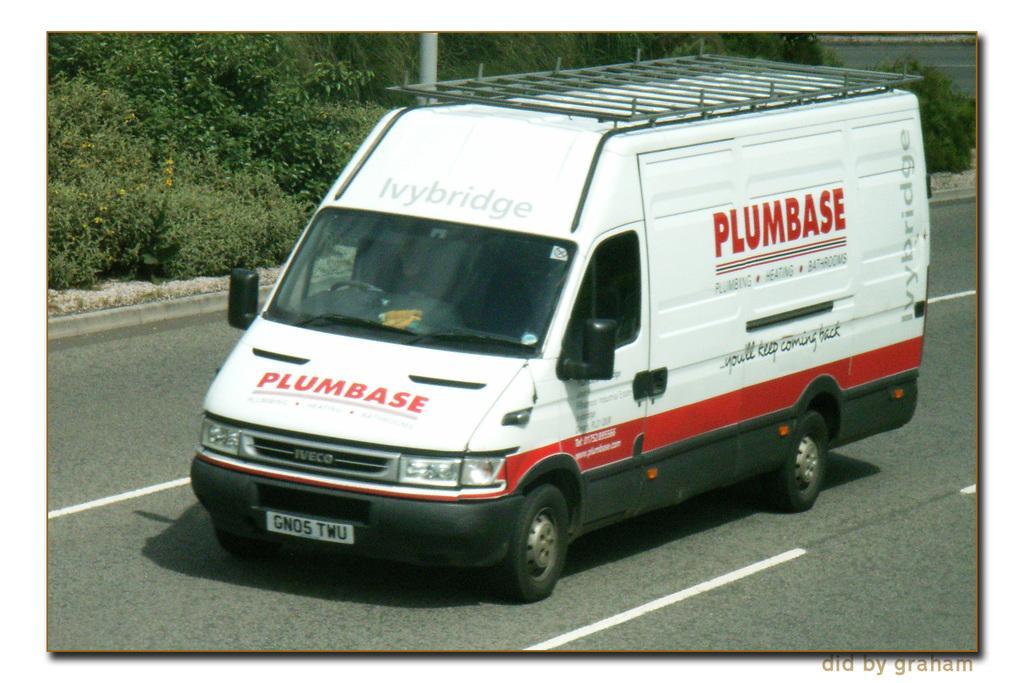Describe this image in one or two sentences. This image is taken outdoors. At the bottom of the image there is a road. In the middle of the image a truck is moving on the road. In the background there are a few plants and a pole. 